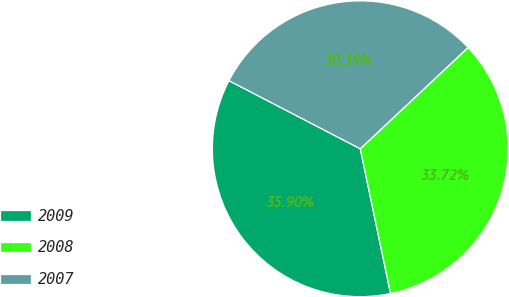Convert chart. <chart><loc_0><loc_0><loc_500><loc_500><pie_chart><fcel>2009<fcel>2008<fcel>2007<nl><fcel>35.9%<fcel>33.72%<fcel>30.38%<nl></chart> 